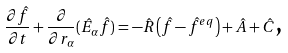<formula> <loc_0><loc_0><loc_500><loc_500>\frac { \partial \hat { f } } { \partial t } + \frac { \partial } { \partial r _ { \alpha } } ( \hat { E } _ { \alpha } \hat { f } ) = - \hat { R } \left ( \hat { f } - \hat { f } ^ { e q } \right ) + \hat { A } + \hat { C } \text {,}</formula> 